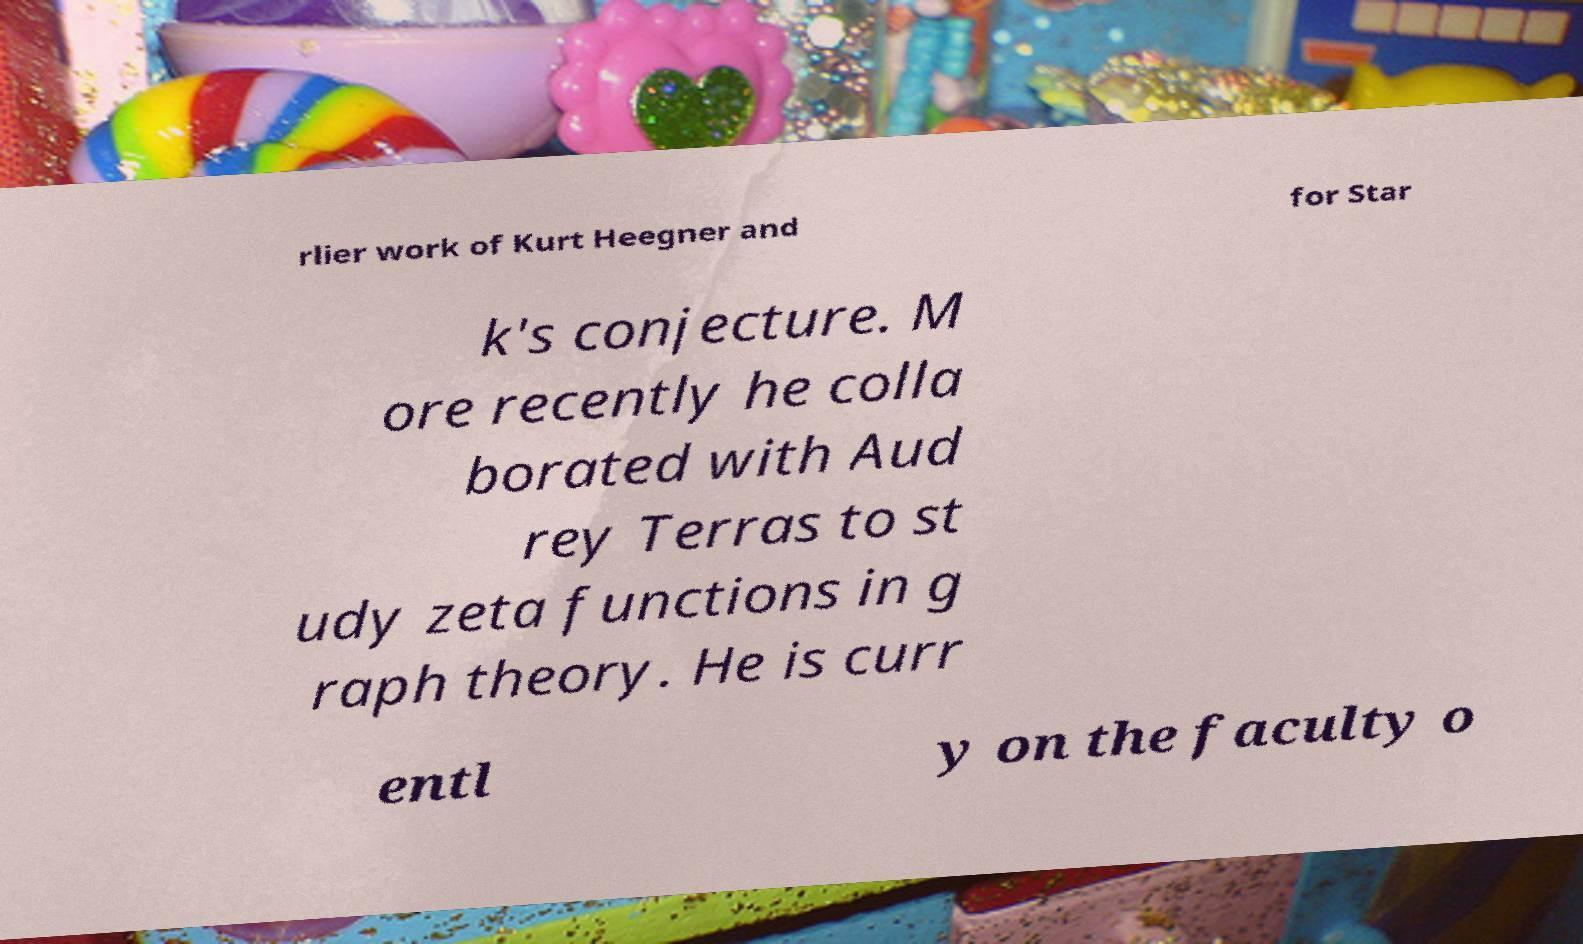Can you read and provide the text displayed in the image?This photo seems to have some interesting text. Can you extract and type it out for me? rlier work of Kurt Heegner and for Star k's conjecture. M ore recently he colla borated with Aud rey Terras to st udy zeta functions in g raph theory. He is curr entl y on the faculty o 